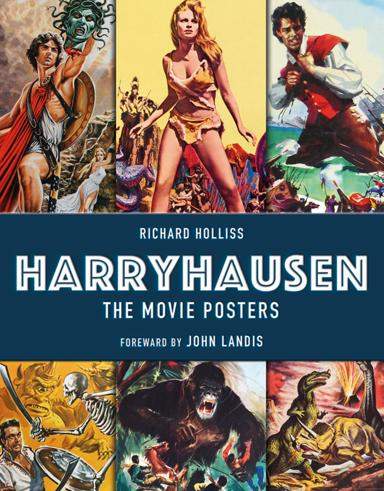Who is responsible for the foreword in the book mentioned in the image? The foreword of the book, which explores the vivid world of Harryhausen's movie posters, is penned by John Landis, a filmmaker known for his appreciation of cinematic history and visual storytelling. 